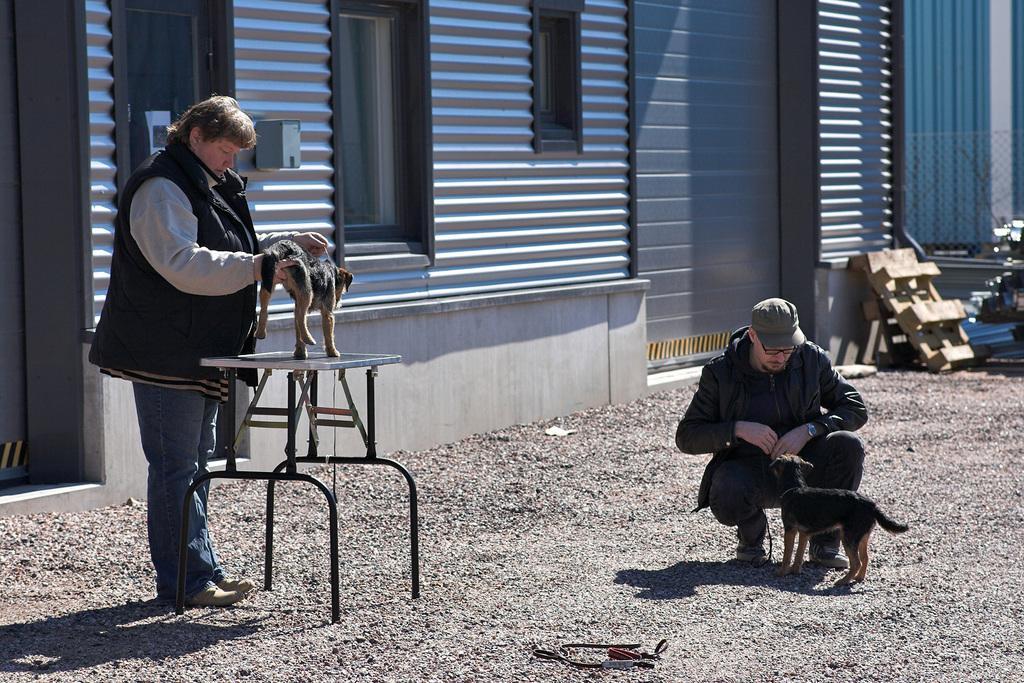Describe this image in one or two sentences. In this image a person wearing a jacket and he is holding an animal which is on the table. Right side a person is before a animal. He is wearing a jacket , cap and spectacles. Right side there are few objects on the land. Behind there is will having windows to it. 